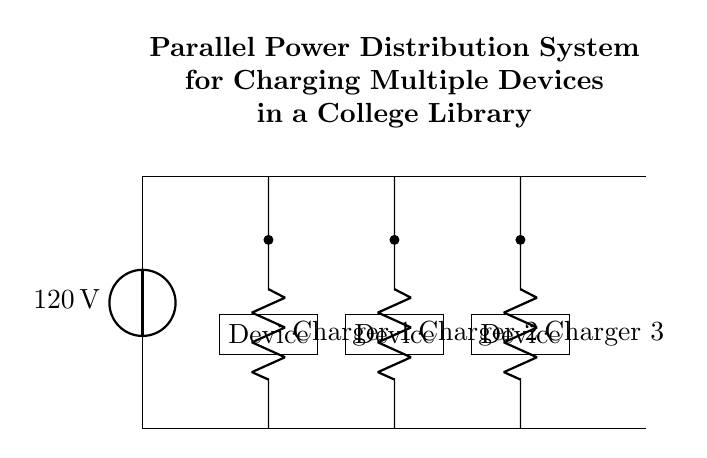What is the voltage supplied to the circuit? The voltage source at the top of the circuit diagram is labeled 120 volts, indicating the potential difference provided to the entire parallel distribution system.
Answer: 120 volts How many charging stations are shown in the circuit? The circuit diagram contains three charging stations, as indicated by the three resistors labeled Charger 1, Charger 2, and Charger 3, positioned along the main line of the circuit.
Answer: Three What are the devices being charged in the circuit? The circuit diagram shows three devices, each represented by a box labeled "Device" positioned under each charging station, indicating that these devices are connected for charging.
Answer: Devices Which component symbolizes the power supply? The circuit includes a voltage source labeled as "120 volts," depicted at the top of the diagram, representing the component that supplies electrical energy to the circuit.
Answer: Voltage source What type of circuit configuration is used here? This circuit is a parallel configuration, as demonstrated by each charging station having its individual connection to the voltage source and being capable of operating independently without affecting one another.
Answer: Parallel How does the current behave in this circuit? In a parallel circuit, the total current supplied from the voltage source divides among the charging stations; therefore, each charger receives the same voltage, but the current through each can vary based on the devices connected to them.
Answer: Divides What happens if one charger fails? In a parallel configuration, if one charger fails, the other chargers will continue to function since they are independently connected to the power source, allowing other devices to charge uninterrupted.
Answer: Other chargers continue to work 